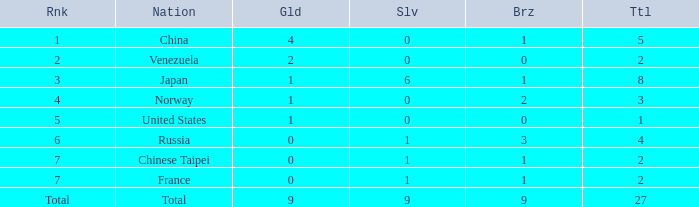What is the sum of Bronze when the total is more than 27? None. 